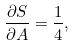Convert formula to latex. <formula><loc_0><loc_0><loc_500><loc_500>\frac { \partial S } { \partial A } = \frac { 1 } { 4 } ,</formula> 